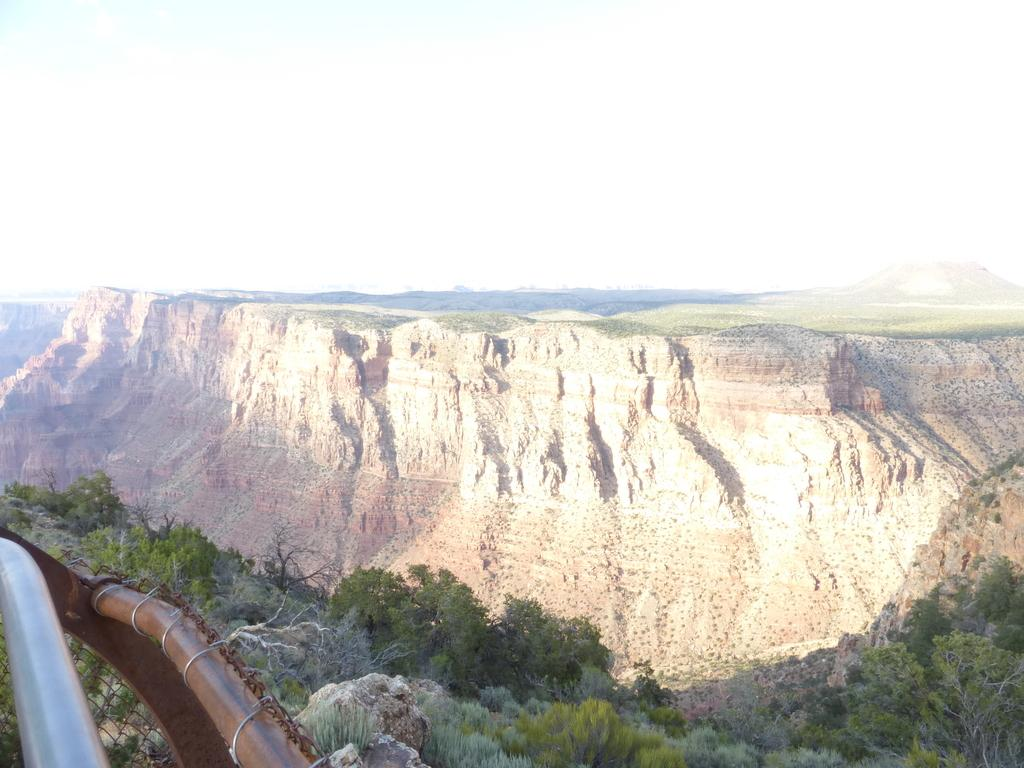What objects are located in the bottom left hand corner of the image? There are metal rods in the bottom left hand corner of the image. What type of natural scenery can be seen in the background of the image? There are trees visible in the background of the image. What type of drain is visible in the image? There is no drain present in the image. Is there an oven visible in the image? There is no oven present in the image. Is there any indication of a birthday celebration in the image? There is no indication of a birthday celebration in the image. 